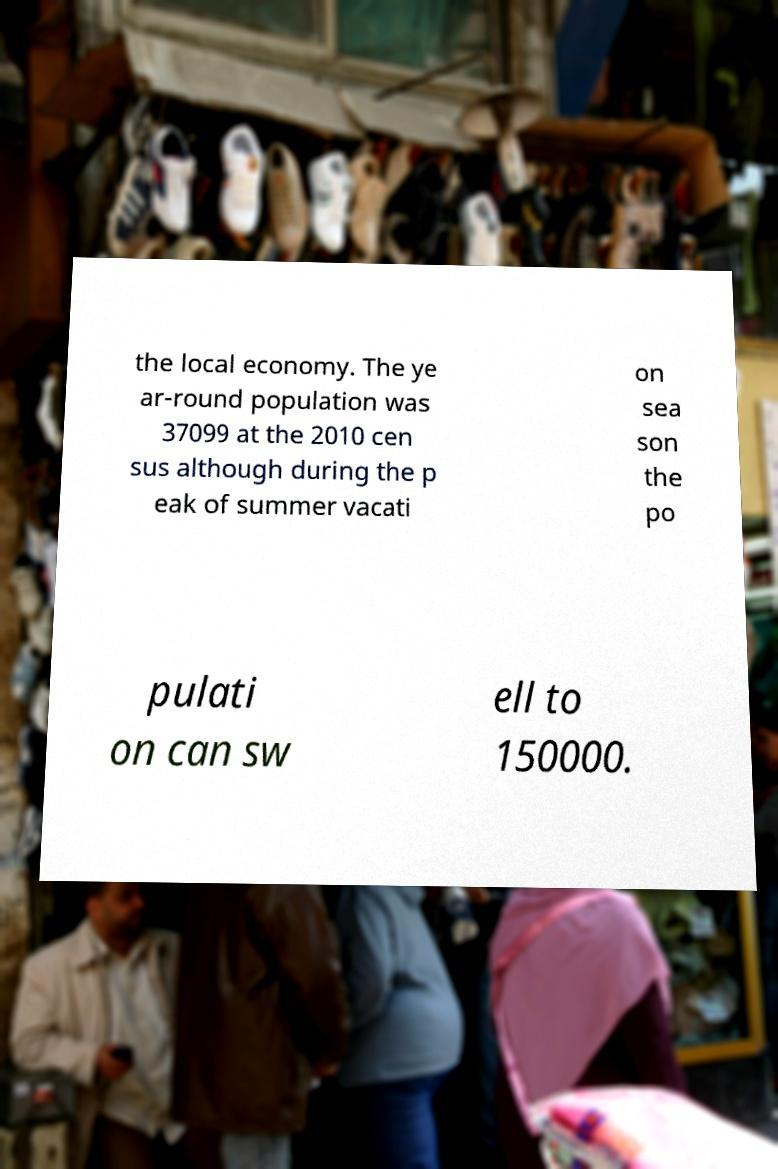Can you read and provide the text displayed in the image?This photo seems to have some interesting text. Can you extract and type it out for me? the local economy. The ye ar-round population was 37099 at the 2010 cen sus although during the p eak of summer vacati on sea son the po pulati on can sw ell to 150000. 